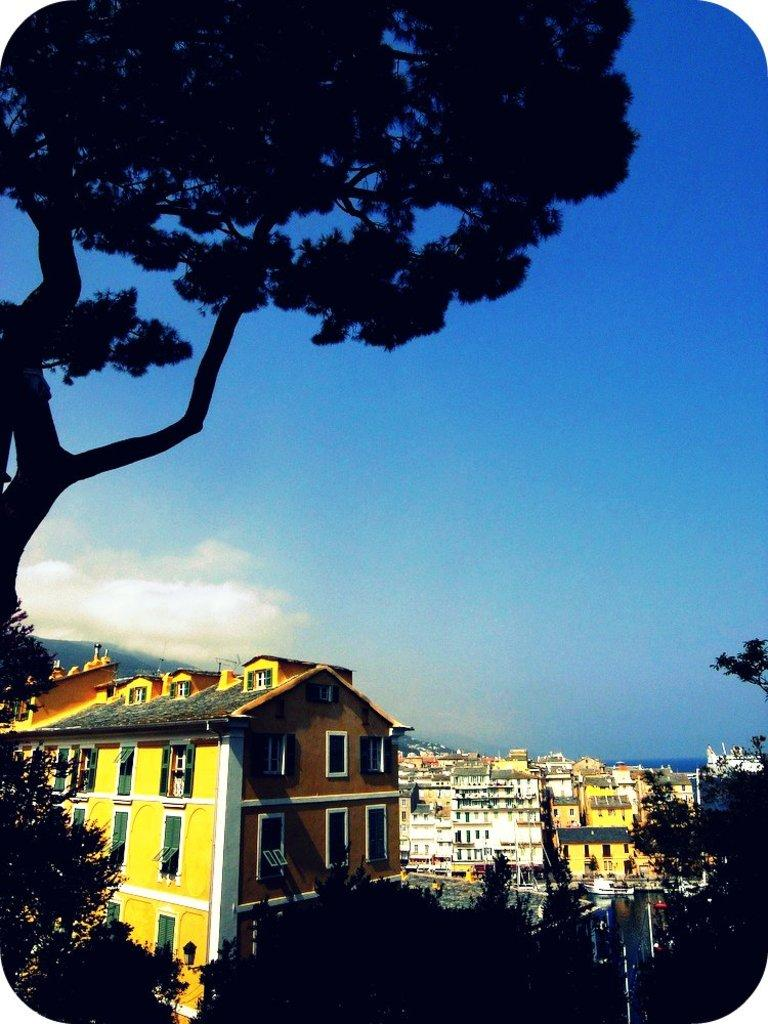What type of natural elements can be seen in the image? There are trees in the image. What type of man-made structures are present in the image? There are buildings in the image. Can you describe the location of one of the trees in the image? One tree is visible at the top of the image. What color is the sky in the background of the image? The sky is blue in the background of the image. What type of copper material is used to construct the boundary in the image? There is no copper material or boundary present in the image. 